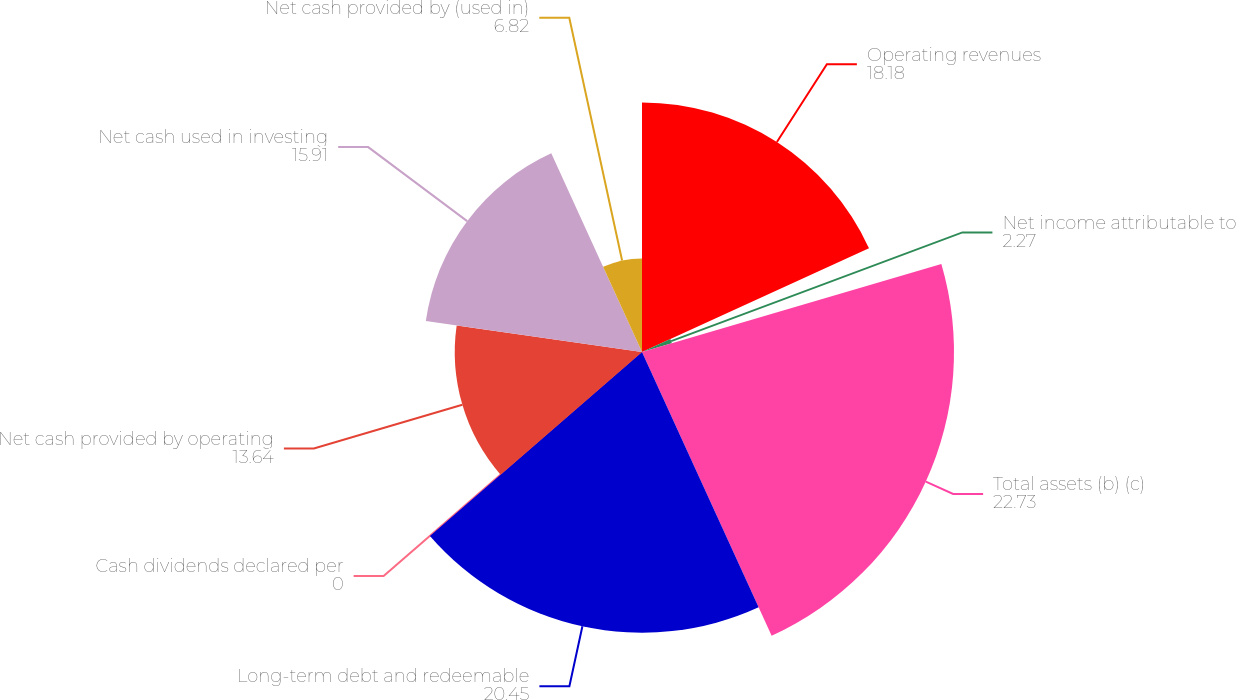Convert chart to OTSL. <chart><loc_0><loc_0><loc_500><loc_500><pie_chart><fcel>Operating revenues<fcel>Net income attributable to<fcel>Total assets (b) (c)<fcel>Long-term debt and redeemable<fcel>Cash dividends declared per<fcel>Net cash provided by operating<fcel>Net cash used in investing<fcel>Net cash provided by (used in)<nl><fcel>18.18%<fcel>2.27%<fcel>22.73%<fcel>20.45%<fcel>0.0%<fcel>13.64%<fcel>15.91%<fcel>6.82%<nl></chart> 